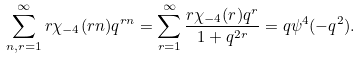Convert formula to latex. <formula><loc_0><loc_0><loc_500><loc_500>\sum _ { n , r = 1 } ^ { \infty } r \chi _ { - 4 } ( r n ) q ^ { r n } = \sum _ { r = 1 } ^ { \infty } \frac { r \chi _ { - 4 } ( r ) q ^ { r } } { 1 + q ^ { 2 r } } = q \psi ^ { 4 } ( - q ^ { 2 } ) .</formula> 